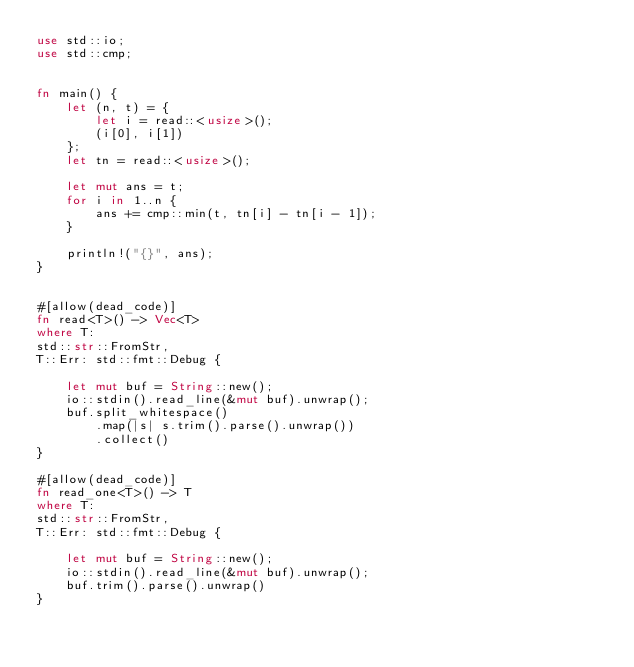<code> <loc_0><loc_0><loc_500><loc_500><_Rust_>use std::io;
use std::cmp;


fn main() {
    let (n, t) = {
        let i = read::<usize>();
        (i[0], i[1])
    };
    let tn = read::<usize>();

    let mut ans = t;
    for i in 1..n {
        ans += cmp::min(t, tn[i] - tn[i - 1]);
    }

    println!("{}", ans);
}


#[allow(dead_code)]
fn read<T>() -> Vec<T>
where T:
std::str::FromStr,
T::Err: std::fmt::Debug {

    let mut buf = String::new();
    io::stdin().read_line(&mut buf).unwrap();
    buf.split_whitespace()
        .map(|s| s.trim().parse().unwrap())
        .collect()
}

#[allow(dead_code)]
fn read_one<T>() -> T
where T:
std::str::FromStr,
T::Err: std::fmt::Debug {

    let mut buf = String::new();
    io::stdin().read_line(&mut buf).unwrap();
    buf.trim().parse().unwrap()
}</code> 